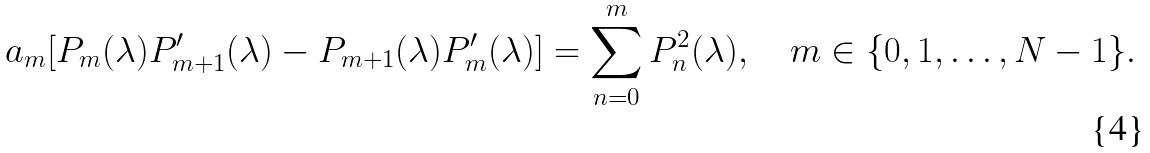<formula> <loc_0><loc_0><loc_500><loc_500>a _ { m } [ P _ { m } ( \lambda ) P _ { m + 1 } ^ { \prime } ( \lambda ) - P _ { m + 1 } ( \lambda ) P _ { m } ^ { \prime } ( \lambda ) ] = \sum _ { n = 0 } ^ { m } P _ { n } ^ { 2 } ( \lambda ) , \quad m \in \{ 0 , 1 , \dots , N - 1 \} .</formula> 